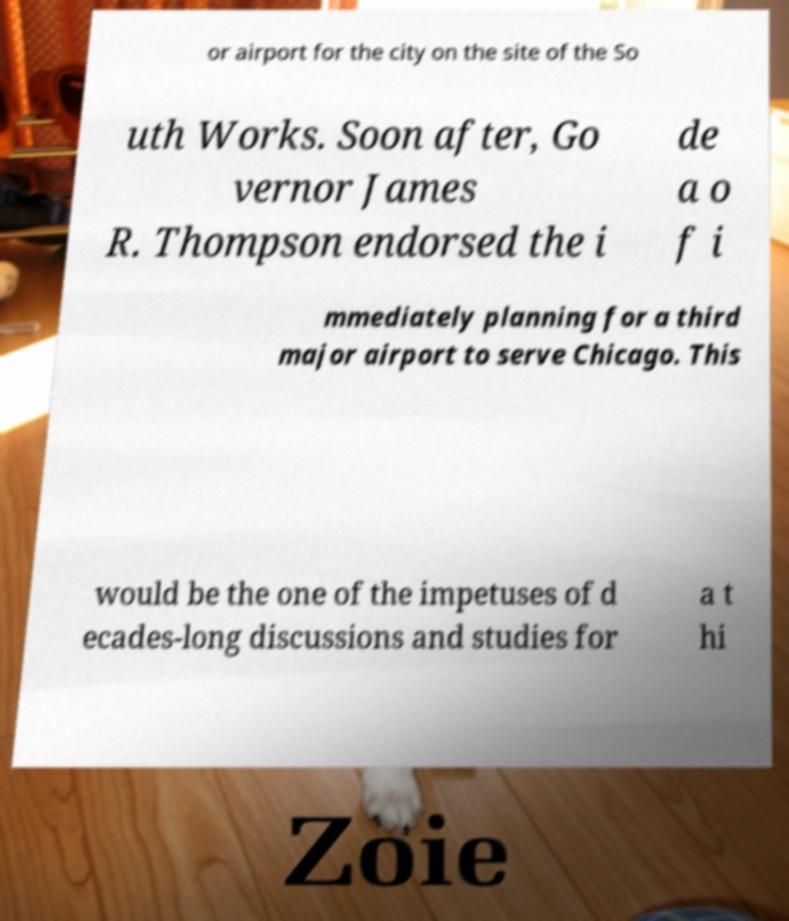I need the written content from this picture converted into text. Can you do that? or airport for the city on the site of the So uth Works. Soon after, Go vernor James R. Thompson endorsed the i de a o f i mmediately planning for a third major airport to serve Chicago. This would be the one of the impetuses of d ecades-long discussions and studies for a t hi 